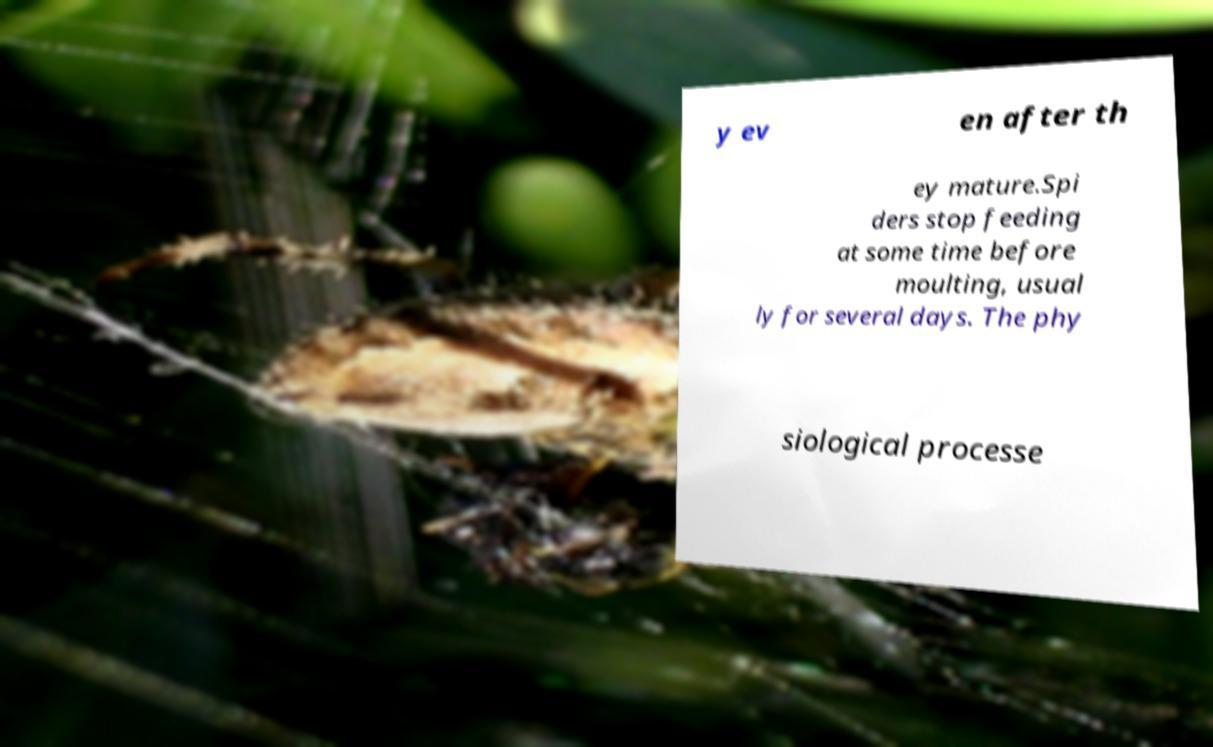There's text embedded in this image that I need extracted. Can you transcribe it verbatim? y ev en after th ey mature.Spi ders stop feeding at some time before moulting, usual ly for several days. The phy siological processe 